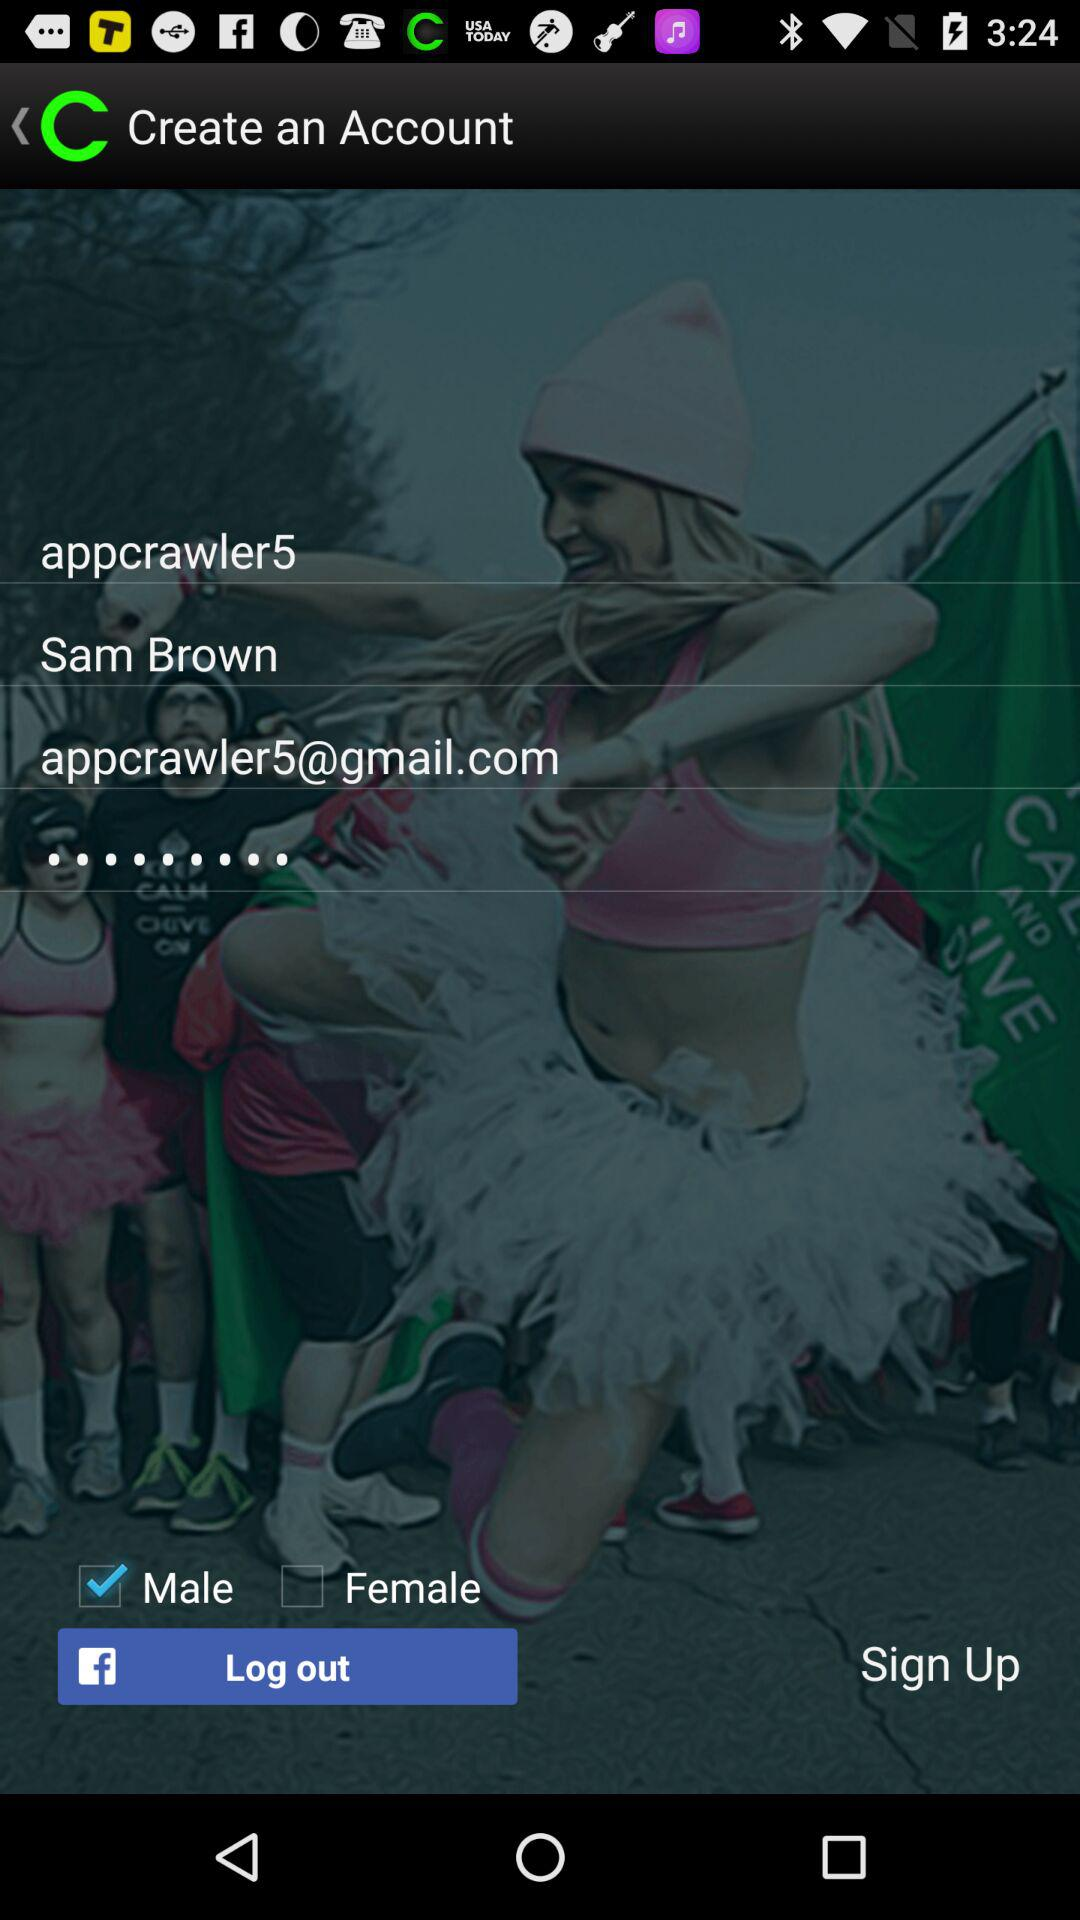What is the name of the user? The name is Sam Brown. 